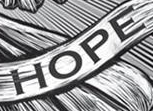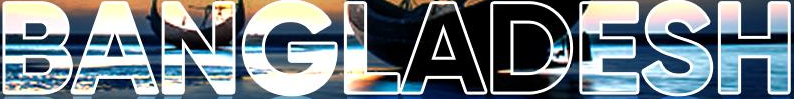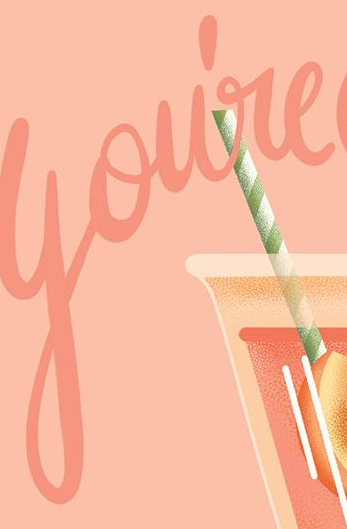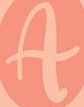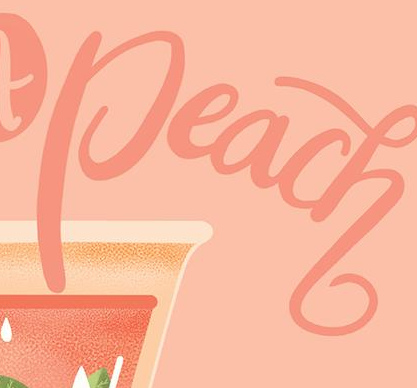Read the text content from these images in order, separated by a semicolon. HOPE; BANGLADESH; You're; A; Peach 